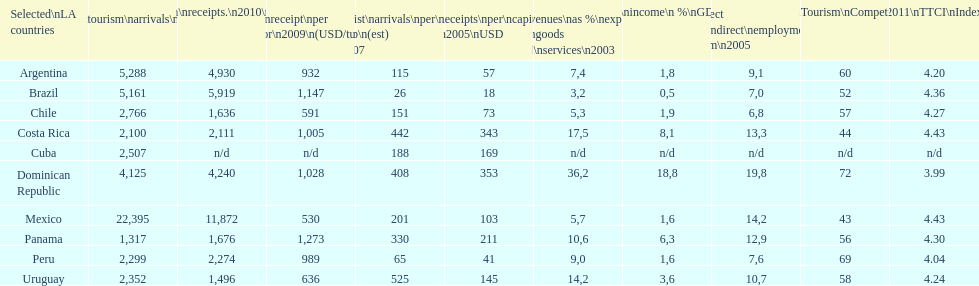How many international tourism arrivals in 2010(x1000) did mexico have? 22,395. Write the full table. {'header': ['Selected\\nLA countries', 'Internl.\\ntourism\\narrivals\\n2010\\n(x 1000)', 'Internl.\\ntourism\\nreceipts.\\n2010\\n(USD\\n(x1000)', 'Avg\\nreceipt\\nper visitor\\n2009\\n(USD/turista)', 'Tourist\\narrivals\\nper\\n1000 inhab\\n(est) \\n2007', 'Receipts\\nper\\ncapita \\n2005\\nUSD', 'Revenues\\nas\xa0%\\nexports of\\ngoods and\\nservices\\n2003', 'Tourism\\nincome\\n\xa0%\\nGDP\\n2003', '% Direct and\\nindirect\\nemployment\\nin tourism\\n2005', 'World\\nranking\\nTourism\\nCompetitiv.\\nTTCI\\n2011', '2011\\nTTCI\\nIndex'], 'rows': [['Argentina', '5,288', '4,930', '932', '115', '57', '7,4', '1,8', '9,1', '60', '4.20'], ['Brazil', '5,161', '5,919', '1,147', '26', '18', '3,2', '0,5', '7,0', '52', '4.36'], ['Chile', '2,766', '1,636', '591', '151', '73', '5,3', '1,9', '6,8', '57', '4.27'], ['Costa Rica', '2,100', '2,111', '1,005', '442', '343', '17,5', '8,1', '13,3', '44', '4.43'], ['Cuba', '2,507', 'n/d', 'n/d', '188', '169', 'n/d', 'n/d', 'n/d', 'n/d', 'n/d'], ['Dominican Republic', '4,125', '4,240', '1,028', '408', '353', '36,2', '18,8', '19,8', '72', '3.99'], ['Mexico', '22,395', '11,872', '530', '201', '103', '5,7', '1,6', '14,2', '43', '4.43'], ['Panama', '1,317', '1,676', '1,273', '330', '211', '10,6', '6,3', '12,9', '56', '4.30'], ['Peru', '2,299', '2,274', '989', '65', '41', '9,0', '1,6', '7,6', '69', '4.04'], ['Uruguay', '2,352', '1,496', '636', '525', '145', '14,2', '3,6', '10,7', '58', '4.24']]} 